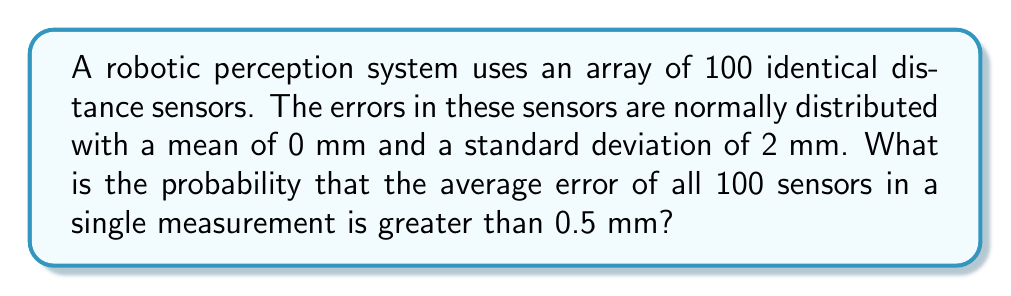Solve this math problem. Let's approach this step-by-step:

1) First, we need to understand what we're dealing with:
   - We have 100 sensors, each with errors that are normally distributed.
   - The mean error for each sensor is $\mu = 0$ mm.
   - The standard deviation of the error for each sensor is $\sigma = 2$ mm.

2) We're interested in the average error of all 100 sensors. This is essentially asking about the sampling distribution of the mean.

3) The Central Limit Theorem tells us that the sampling distribution of the mean will be normally distributed with:
   - Mean: $\mu_{\bar{X}} = \mu = 0$ mm
   - Standard Error: $SE_{\bar{X}} = \frac{\sigma}{\sqrt{n}} = \frac{2}{\sqrt{100}} = 0.2$ mm

4) We want to find $P(\bar{X} > 0.5)$, where $\bar{X}$ is the average error.

5) To standardize this, we calculate the z-score:
   $$z = \frac{0.5 - \mu_{\bar{X}}}{SE_{\bar{X}}} = \frac{0.5 - 0}{0.2} = 2.5$$

6) Now we need to find $P(Z > 2.5)$ where $Z$ is a standard normal variable.

7) Using a standard normal table or calculator, we can find that:
   $P(Z > 2.5) \approx 0.0062$

Therefore, the probability that the average error of all 100 sensors in a single measurement is greater than 0.5 mm is approximately 0.0062 or 0.62%.
Answer: 0.0062 